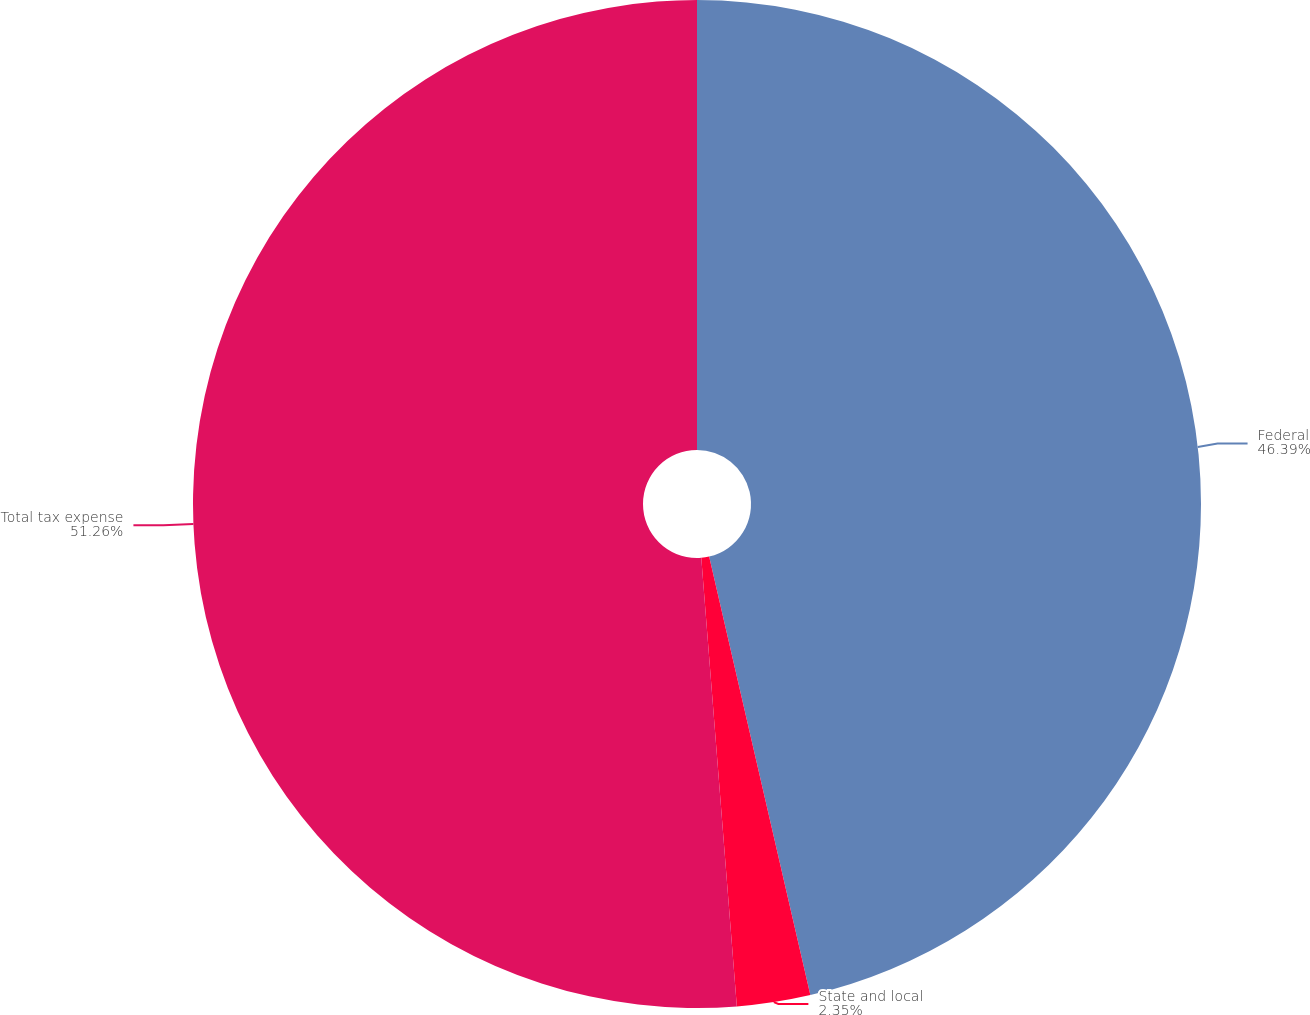Convert chart. <chart><loc_0><loc_0><loc_500><loc_500><pie_chart><fcel>Federal<fcel>State and local<fcel>Total tax expense<nl><fcel>46.39%<fcel>2.35%<fcel>51.26%<nl></chart> 